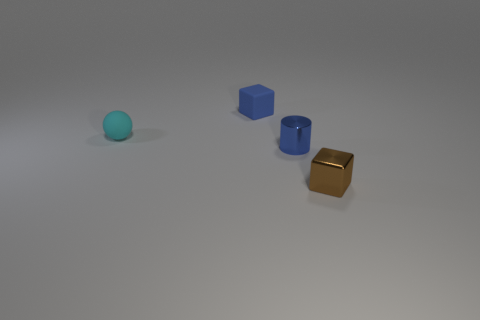Add 3 small metal objects. How many objects exist? 7 Subtract all cylinders. How many objects are left? 3 Add 2 tiny gray matte cylinders. How many tiny gray matte cylinders exist? 2 Subtract 0 red blocks. How many objects are left? 4 Subtract all balls. Subtract all cyan matte objects. How many objects are left? 2 Add 4 small metallic blocks. How many small metallic blocks are left? 5 